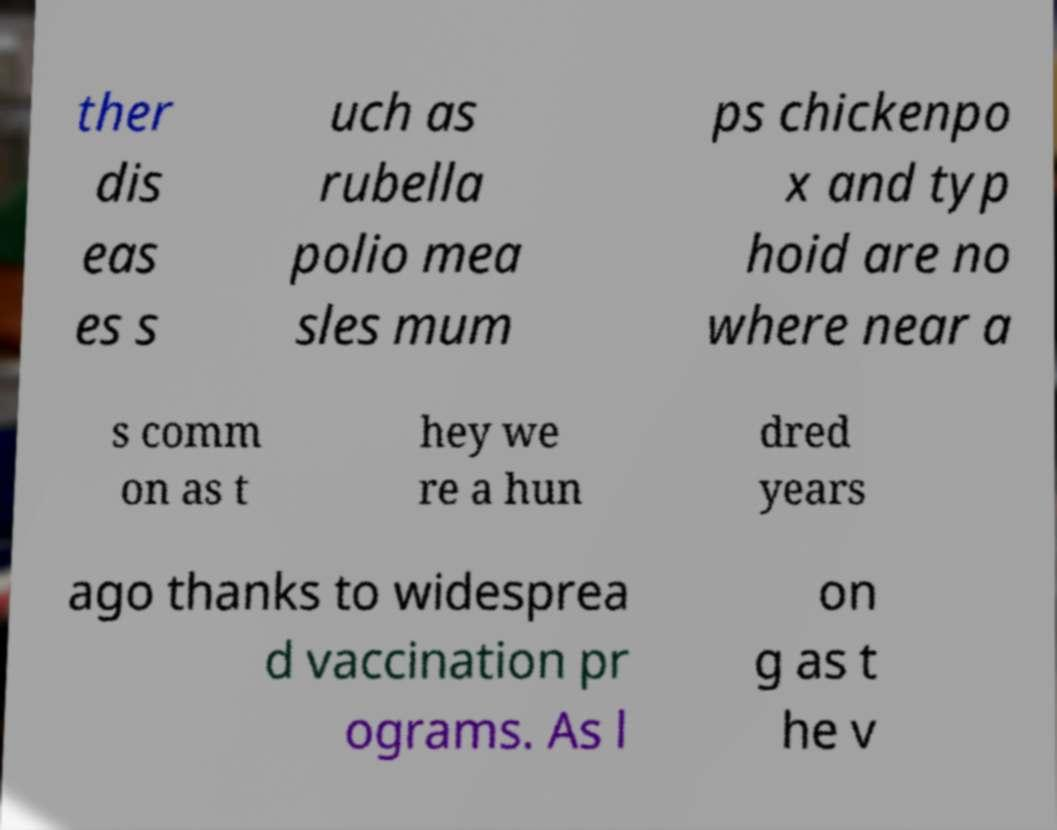Please read and relay the text visible in this image. What does it say? ther dis eas es s uch as rubella polio mea sles mum ps chickenpo x and typ hoid are no where near a s comm on as t hey we re a hun dred years ago thanks to widesprea d vaccination pr ograms. As l on g as t he v 